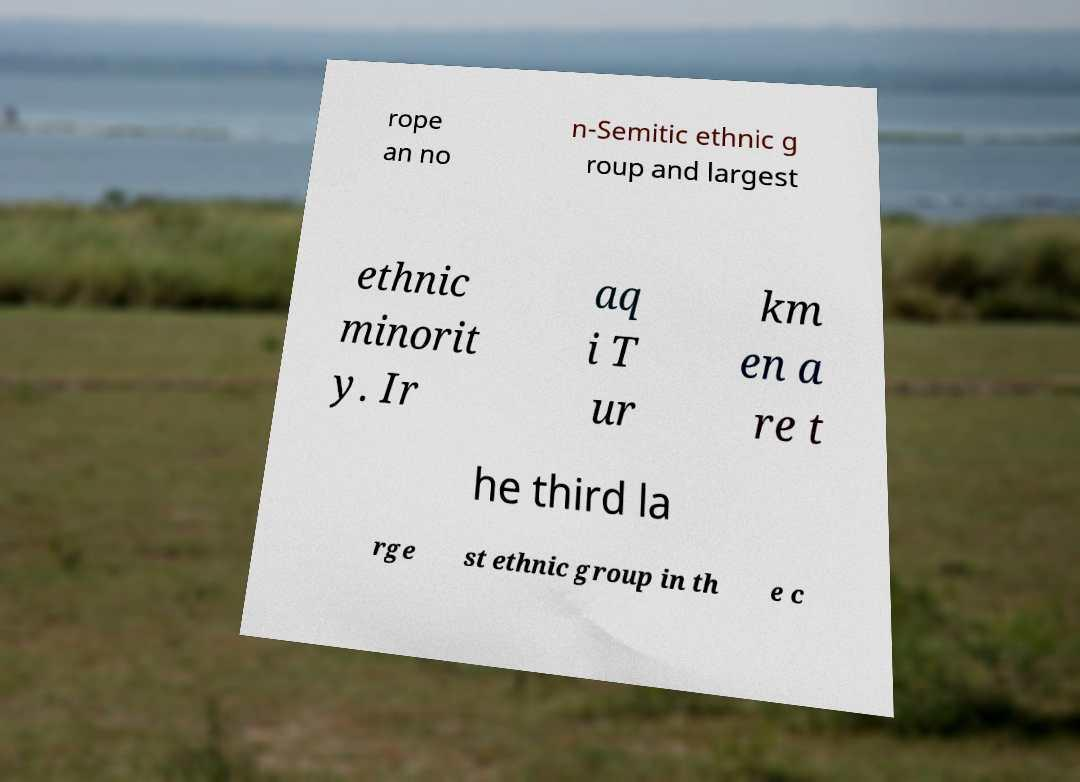Can you read and provide the text displayed in the image?This photo seems to have some interesting text. Can you extract and type it out for me? rope an no n-Semitic ethnic g roup and largest ethnic minorit y. Ir aq i T ur km en a re t he third la rge st ethnic group in th e c 